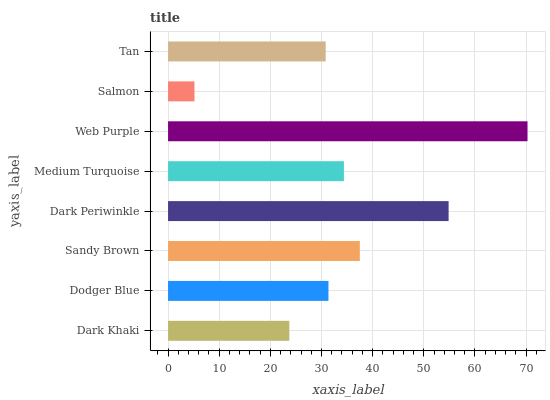Is Salmon the minimum?
Answer yes or no. Yes. Is Web Purple the maximum?
Answer yes or no. Yes. Is Dodger Blue the minimum?
Answer yes or no. No. Is Dodger Blue the maximum?
Answer yes or no. No. Is Dodger Blue greater than Dark Khaki?
Answer yes or no. Yes. Is Dark Khaki less than Dodger Blue?
Answer yes or no. Yes. Is Dark Khaki greater than Dodger Blue?
Answer yes or no. No. Is Dodger Blue less than Dark Khaki?
Answer yes or no. No. Is Medium Turquoise the high median?
Answer yes or no. Yes. Is Dodger Blue the low median?
Answer yes or no. Yes. Is Web Purple the high median?
Answer yes or no. No. Is Dark Khaki the low median?
Answer yes or no. No. 